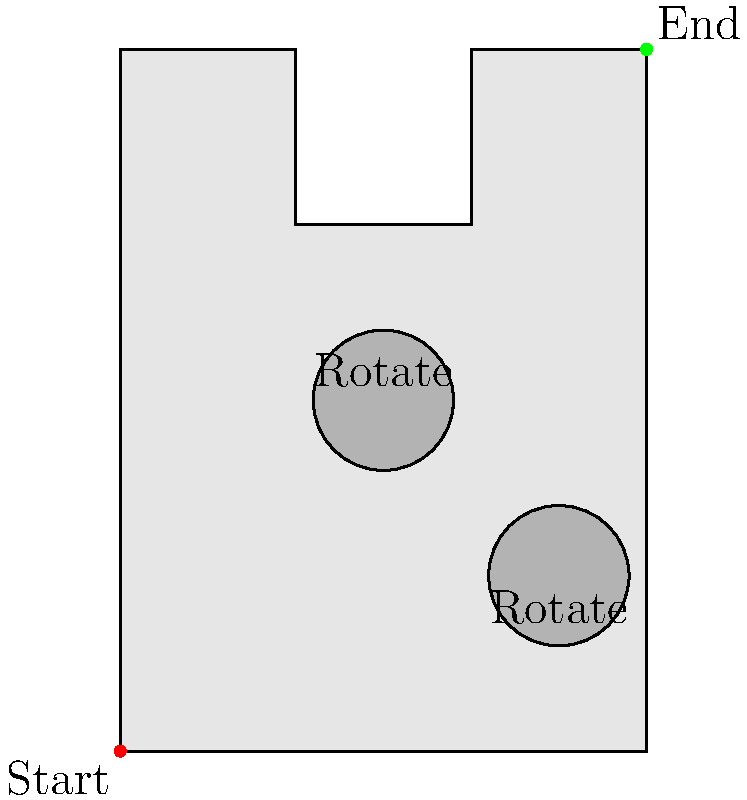Hey, troublemaker! Remember our wild adventures in Grapeland? Well, I've got a tricky maze for you. To reach the end, you need to rotate the circular obstacles. If you can only rotate each obstacle 90° clockwise or counterclockwise, what's the minimum number of rotations needed to create a clear path from start to finish? Let's approach this step-by-step:

1. The maze has two circular obstacles that can be rotated.
2. We need to create a clear path from the bottom-left (start) to the top-right (end).
3. Each obstacle can be rotated 90° clockwise or counterclockwise.
4. Let's analyze each obstacle:
   a) The first obstacle (top circle) blocks the path horizontally.
   b) The second obstacle (bottom circle) blocks the path vertically.
5. To create a clear path:
   a) We need to rotate the first obstacle 90° in either direction to allow horizontal passage.
   b) We need to rotate the second obstacle 90° in either direction to allow vertical passage.
6. Each of these rotations counts as one move.
7. Therefore, we need a minimum of two rotations (one for each obstacle) to create a clear path.

This solution assumes the most efficient path and minimal rotations needed.
Answer: 2 rotations 